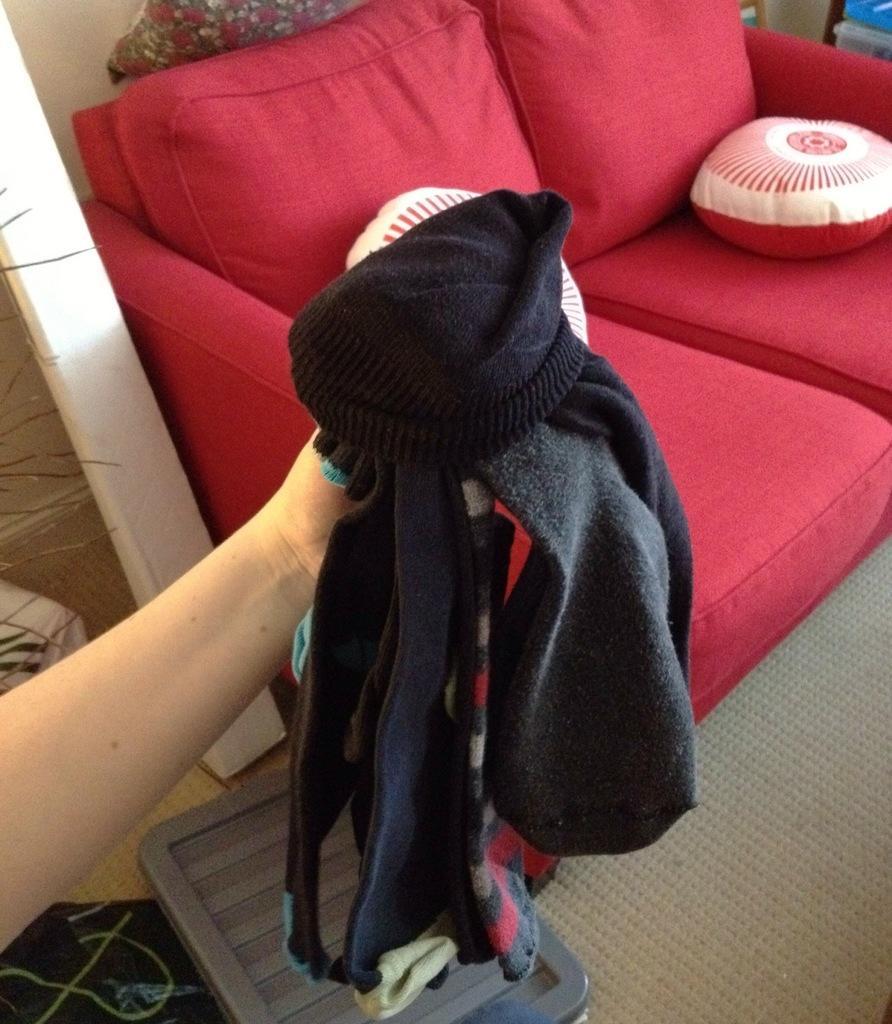How would you summarize this image in a sentence or two? In this image on the right side there is one red couch and on the couch there are two pillows and on the left side one person hand is there and she is holding some clothes and on the top of the left corner there is one pillar and on the floor there is one carpet. 